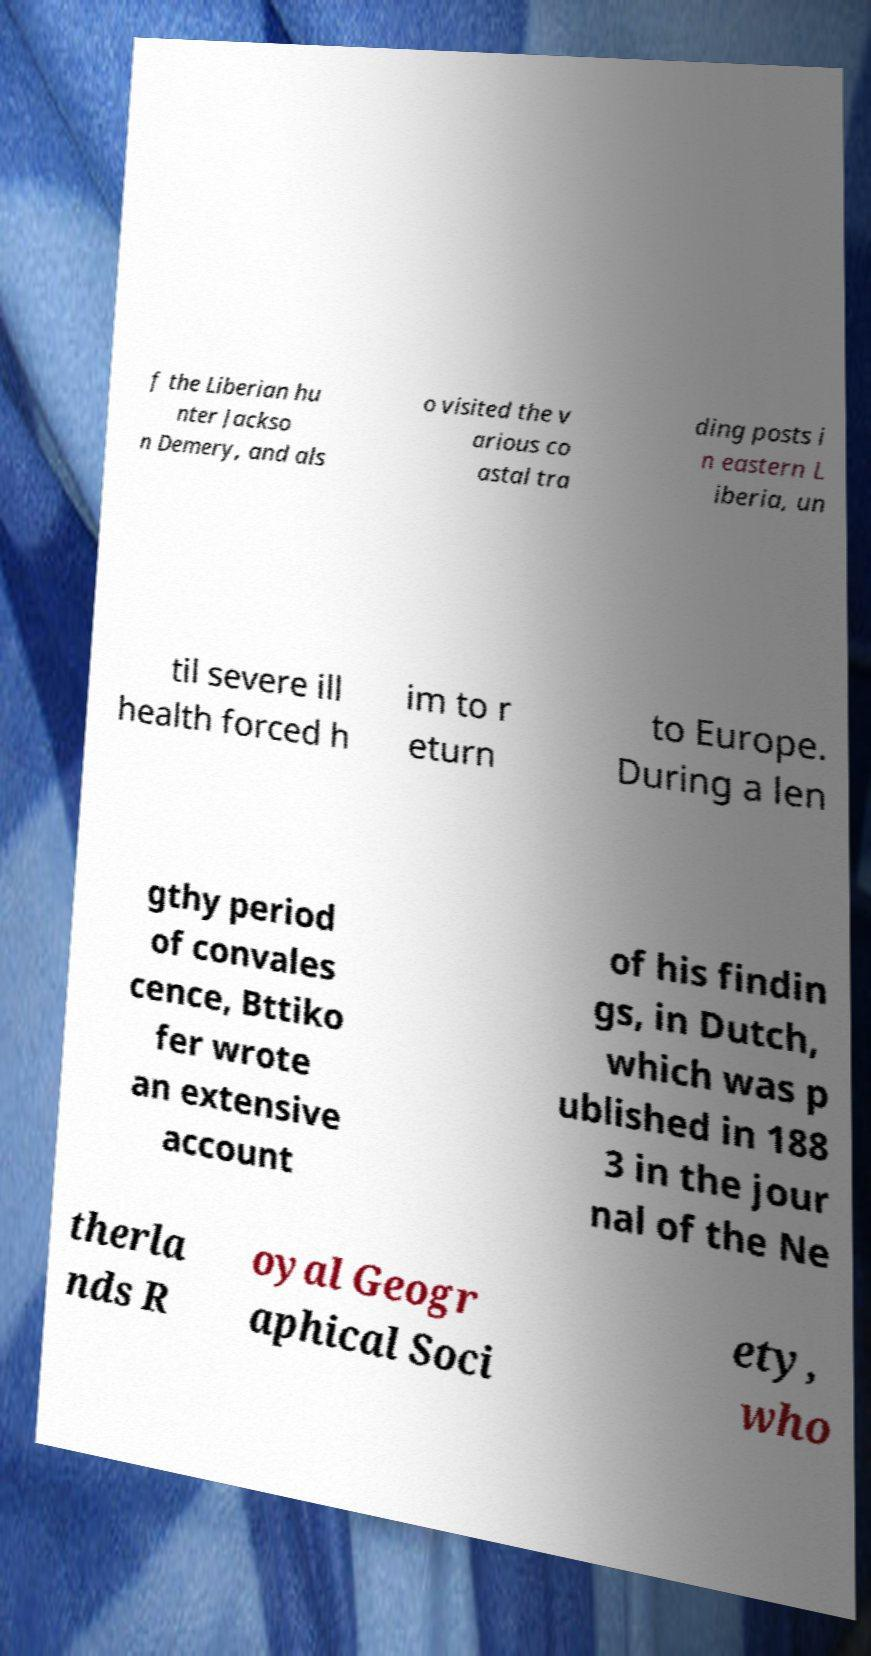For documentation purposes, I need the text within this image transcribed. Could you provide that? f the Liberian hu nter Jackso n Demery, and als o visited the v arious co astal tra ding posts i n eastern L iberia, un til severe ill health forced h im to r eturn to Europe. During a len gthy period of convales cence, Bttiko fer wrote an extensive account of his findin gs, in Dutch, which was p ublished in 188 3 in the jour nal of the Ne therla nds R oyal Geogr aphical Soci ety, who 